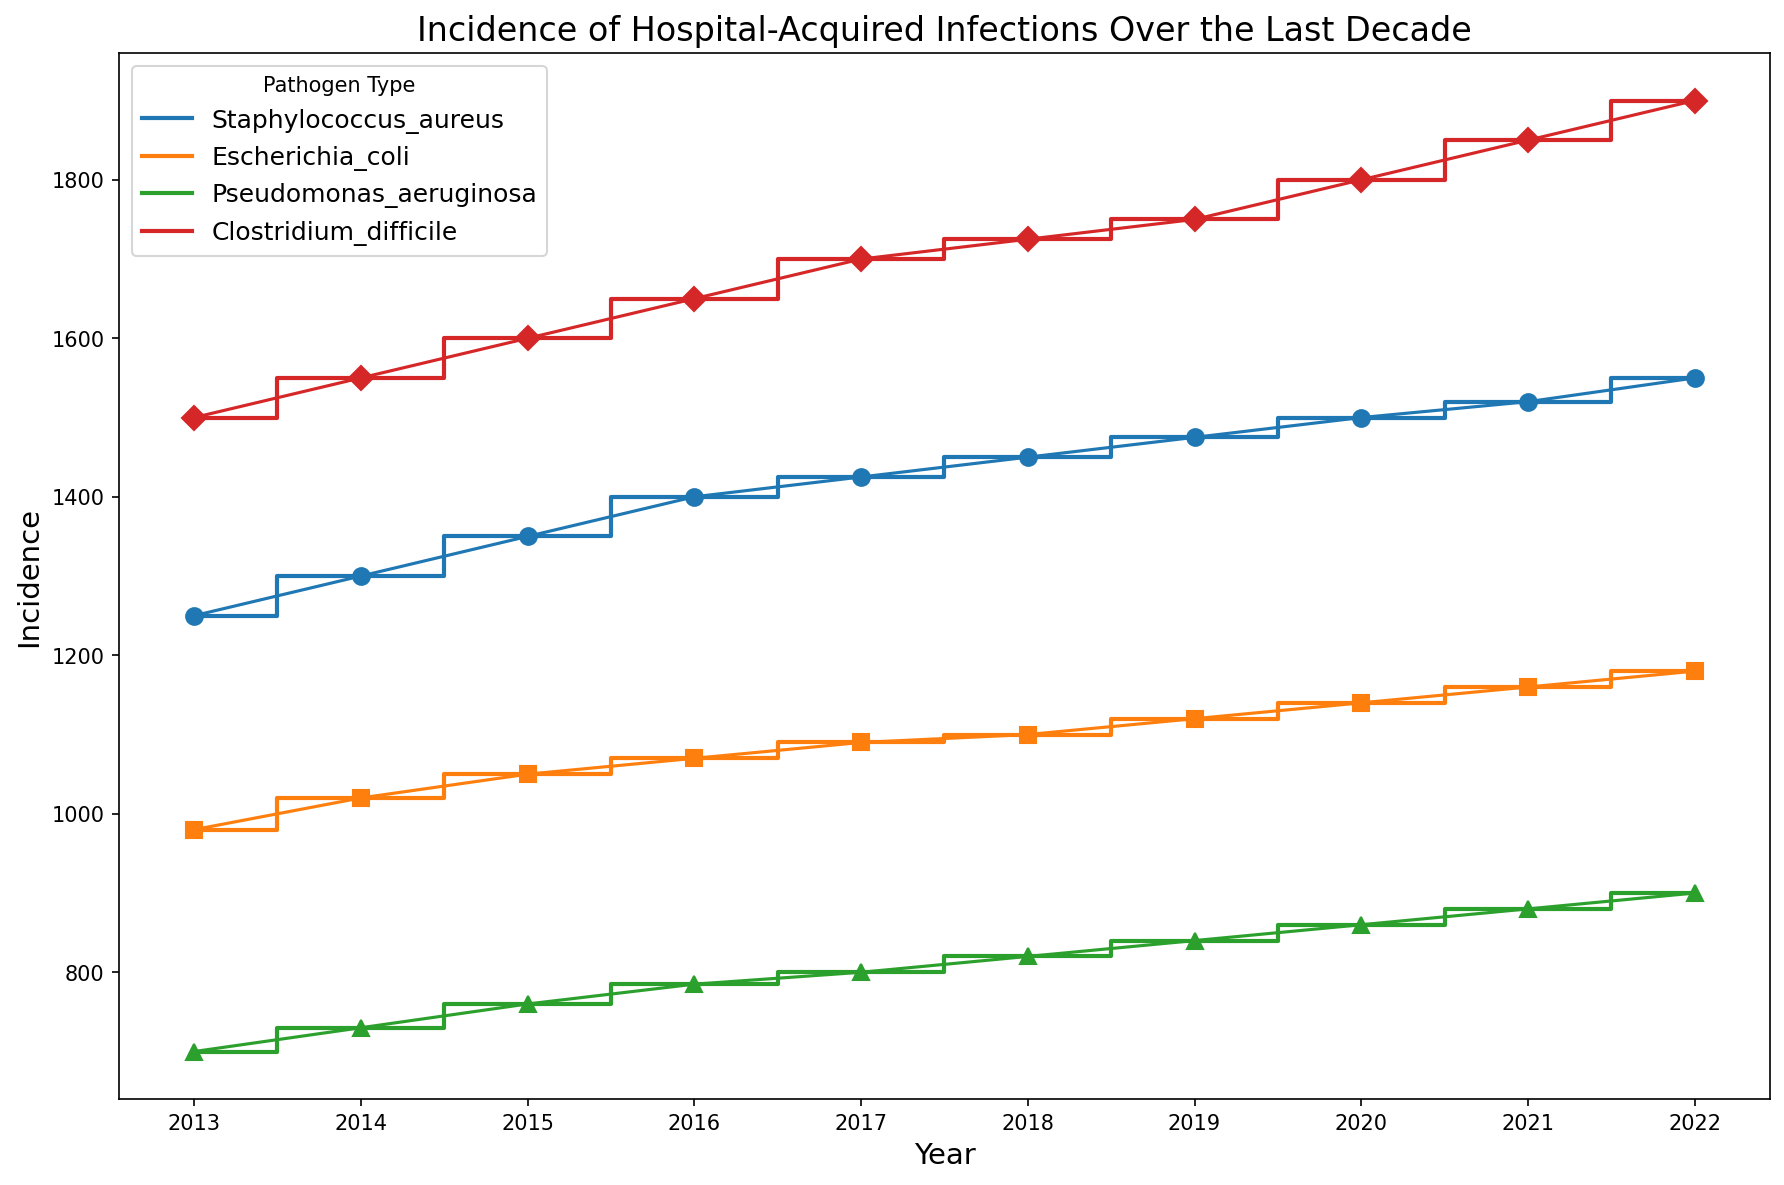What's the trend in the incidence of hospital-acquired infections for Staphylococcus aureus over the last decade? To see the trend, look at the step plots and markers for 'Staphylococcus aureus' (blue color) from 2013 to 2022. The incidence value steadily increases each year.
Answer: Increasing Which pathogen had the highest incidence in 2022 and what was the value? In the plot, find the highest point in 2022. The red diamond marker for 'Clostridium difficile' at 1900 is the highest.
Answer: Clostridium difficile, 1900 Compare the incidence of Escherichia coli and Pseudomonas aeruginosa in 2020. Which is higher and by how much? From the plot, for 2020, 'Escherichia coli' (orange square marker) is at 1140, and 'Pseudomonas aeruginosa' (green triangle marker) is at 860. Subtract the lower value from the higher value: 1140 - 860 = 280.
Answer: Escherichia coli, by 280 What is the average incidence across all pathogens in 2017? Look at the incidence values for 2017: Staphylococcus aureus (1425), Escherichia coli (1090), Pseudomonas aeruginosa (800), Clostridium difficile (1700). Calculate the average: (1425 + 1090 + 800 + 1700) / 4 = 5025 / 4 = 1256.25.
Answer: 1256.25 Which pathogen has shown the most consistent increase in incidence over the years? By analyzing all four plots, 'Clostridium difficile' (red color) shows a near-perfect steady increase without any dips or irregularities.
Answer: Clostridium difficile What is the difference in incidence between the highest peak and the lowest trough for Pseudomonas aeruginosa? The highest peak for 'Pseudomonas aeruginosa' (green triangles) is in 2022 at 900, and the lowest trough is in 2013 at 700. Calculate the difference: 900 - 700 = 200.
Answer: 200 Between which two consecutive years did Escherichia coli see the largest increase in incidence? By looking at 'Escherichia coli' (orange squares) and comparing year-by-year changes: 
2013-2014: 1020 - 980 = 40 
2014-2015: 1050 - 1020 = 30 
2015-2016: 1070 - 1050 = 20 
2016-2017: 1090 - 1070 = 20 
2017-2018: 1100 - 1090 = 10 
2018-2019: 1120 - 1100 = 20 
2019-2020: 1140 - 1120 = 20 
2020-2021: 1160 - 1140 = 20 
2021-2022: 1180 - 1160 = 20 The largest increase is 40 between 2013 and 2014.
Answer: 2013-2014 Which pathogen type shows a more fluctuating pattern in incidence compared to others? By comparing each pathogen's visual plot and markers, 'Pseudomonas aeruginosa' (green triangles) shows less steady increments compared to others, which mostly show more consistent increases.
Answer: Pseudomonas aeruginosa What was the combined incidence of Staphylococcus aureus and Clostridium difficile in 2015? Look at the incidence values for 2015: Staphylococcus aureus (1350) and Clostridium difficile (1600). Add them together: 1350 + 1600 = 2950.
Answer: 2950 